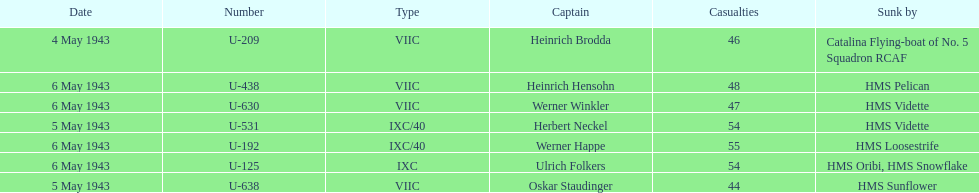Which ship sunk the most u-boats HMS Vidette. 